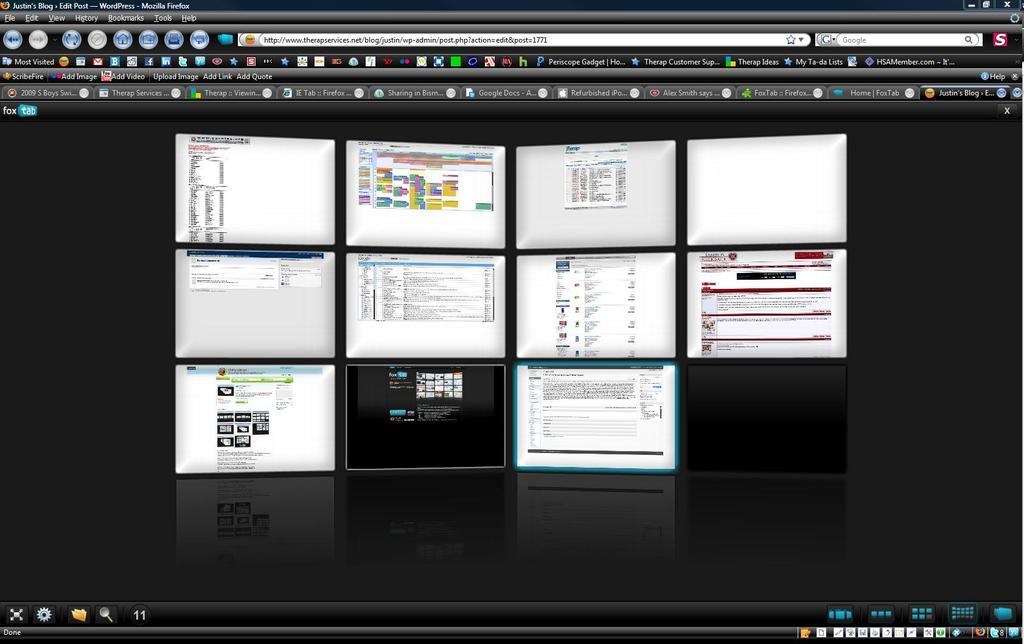<image>
Summarize the visual content of the image. mozilla firefox computer browser screen that is black and has ten smaller pictures of screens on it 